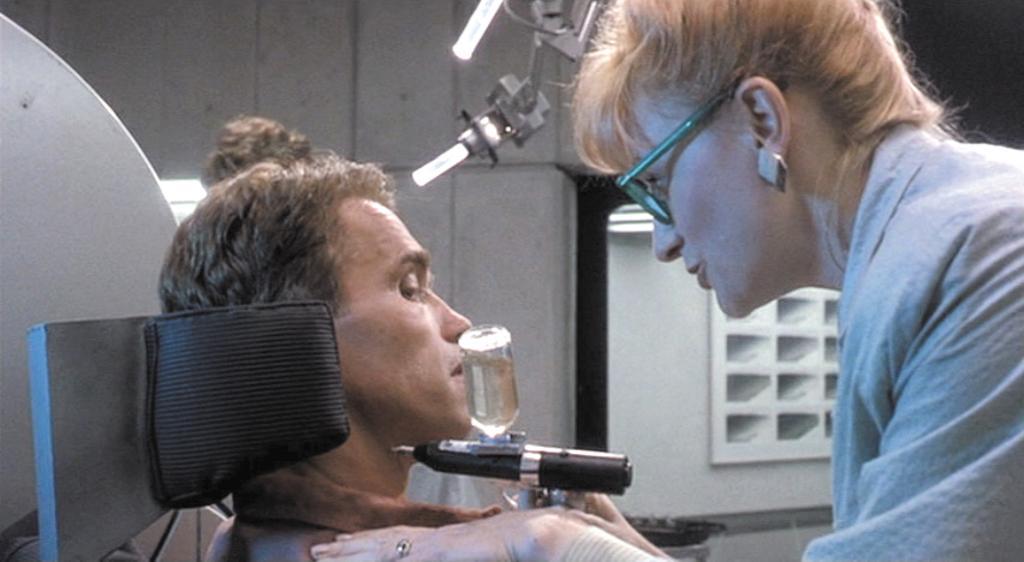Could you give a brief overview of what you see in this image? In the picture we can see women wearing spectacles holding some machine in her hands, there is a person sitting and there is a machine and in the background there is a wall. 